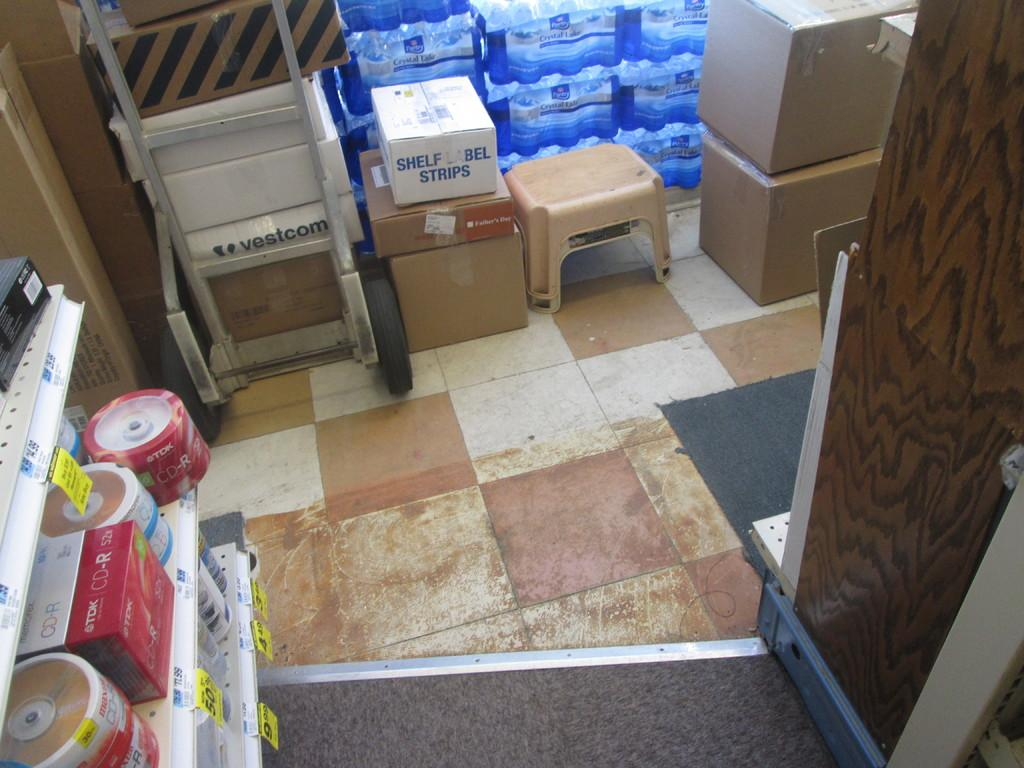What objects are present in the image? There are boxes in the image. What is the surface on which the boxes are placed? The boxes are kept on a marble surface. Can you describe the arrangement of the boxes in the image? Some boxes are visible at the top of the image. What type of education is being provided to the man in the image? There is no man present in the image, and therefore no education is being provided. 